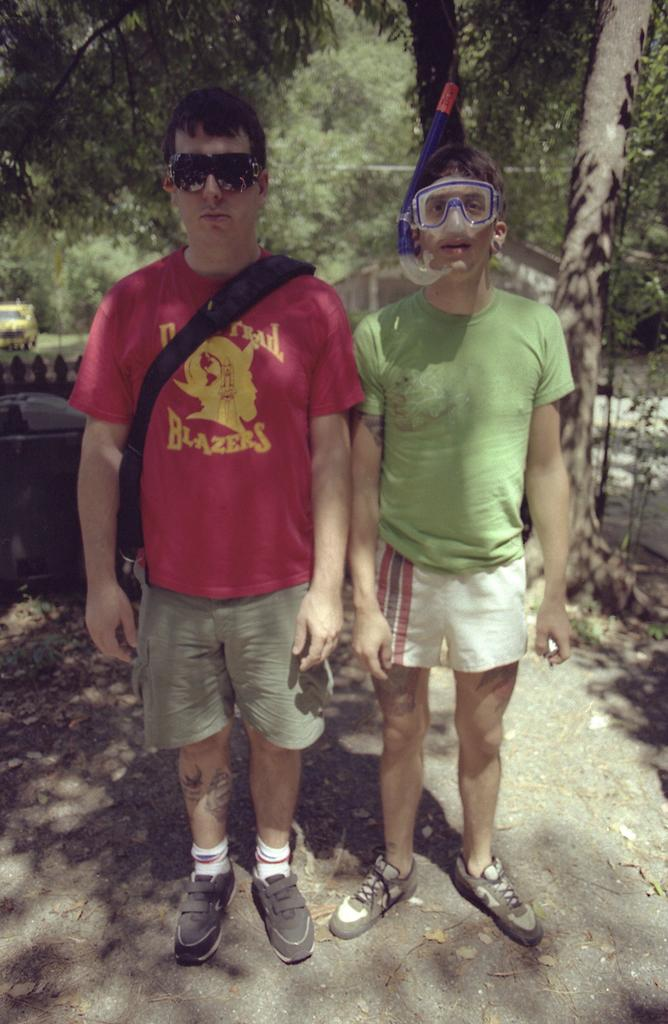What is the position of the first man in the image? The first man is standing on the left side of the image. What is the first man wearing? The first man is wearing a red t-shirt. Who is standing beside the first man? The second man is standing beside the first man. What is the second man wearing? The second man is wearing a green t-shirt. What can be seen in the background of the image? There are green trees visible in the background of the image. How does the first man tie a knot in his t-shirt in the image? There is no indication in the image that the first man is tying a knot in his t-shirt. What type of dress is the woman wearing in the image? There is no woman or dress present in the image. 